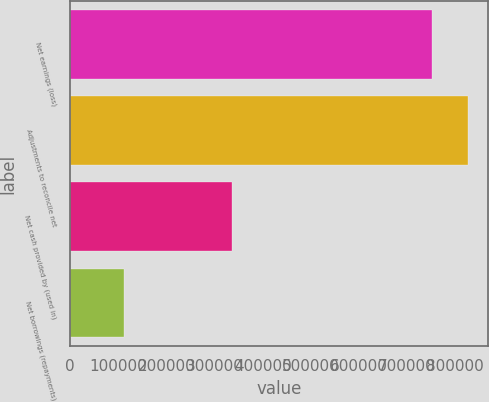Convert chart to OTSL. <chart><loc_0><loc_0><loc_500><loc_500><bar_chart><fcel>Net earnings (loss)<fcel>Adjustments to reconcile net<fcel>Net cash provided by (used in)<fcel>Net borrowings (repayments)<nl><fcel>751391<fcel>826530<fcel>335687<fcel>112963<nl></chart> 